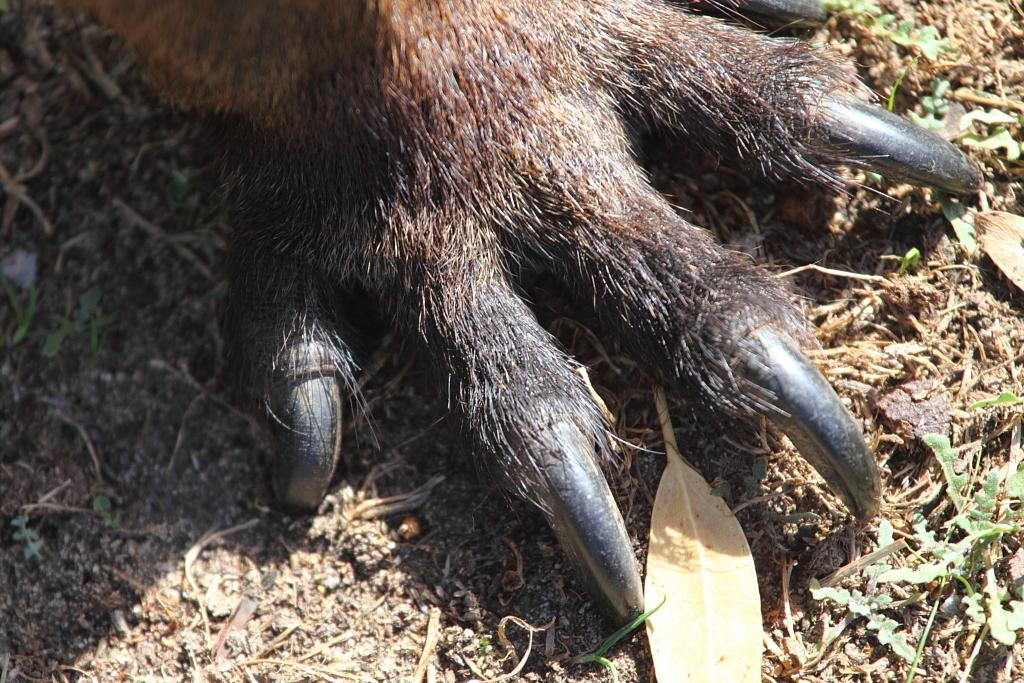What part of an animal can be seen in the image? There is an animal's leg in the image. What type of vegetation is present in the image? There is grass and leaves in the image. What is the animal's desire in the image? There is no indication of the animal's desires in the image, as it only shows a leg and not the animal's face or body language. 